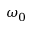<formula> <loc_0><loc_0><loc_500><loc_500>\omega _ { 0 }</formula> 